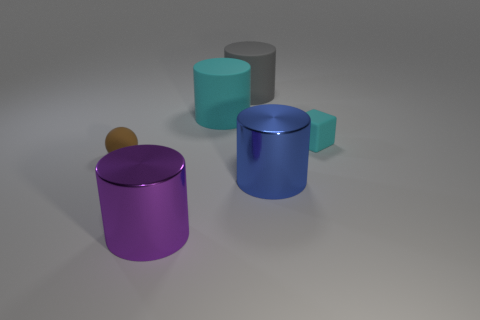Add 2 cyan cylinders. How many objects exist? 8 Subtract all purple balls. Subtract all cyan cylinders. How many balls are left? 1 Subtract all cubes. How many objects are left? 5 Add 6 rubber objects. How many rubber objects exist? 10 Subtract 0 blue spheres. How many objects are left? 6 Subtract all big cylinders. Subtract all large cyan matte cylinders. How many objects are left? 1 Add 1 cubes. How many cubes are left? 2 